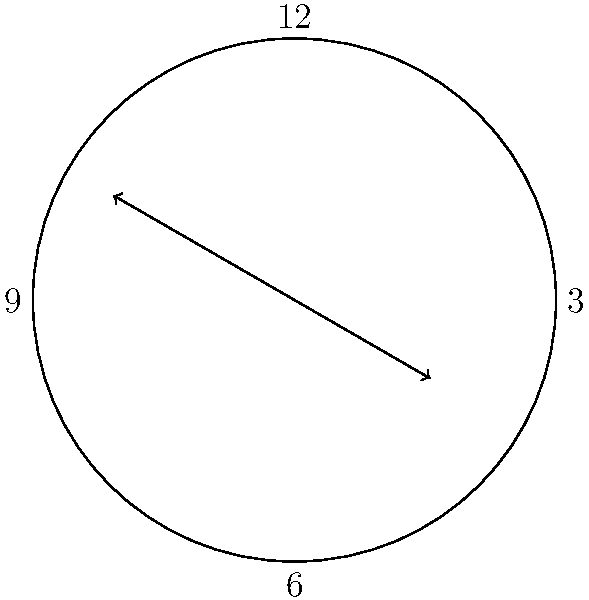The Matchett family's antique clock in their living room shows 2:40. What is the acute angle formed between the hour and minute hands? To find the acute angle between the clock hands, we need to:

1) Calculate the angle of the hour hand from 12 o'clock:
   - Each hour represents 30° (360° / 12 = 30°)
   - At 2:40, the hour hand has moved 2 hours and 40 minutes
   - Angle = $2 * 30° + (40/60) * 30° = 60° + 20° = 80°$

2) Calculate the angle of the minute hand from 12 o'clock:
   - Each minute represents 6° (360° / 60 = 6°)
   - At 40 minutes past, the angle is: $40 * 6° = 240°$

3) Find the absolute difference between these angles:
   $|240° - 80°| = 160°$

4) If this difference is greater than 180°, subtract it from 360° to get the acute angle:
   $360° - 160° = 200°$

5) The acute angle is the smaller of 160° and 200°, which is 160°.

Therefore, the acute angle between the hour and minute hands is 160°.
Answer: 160° 